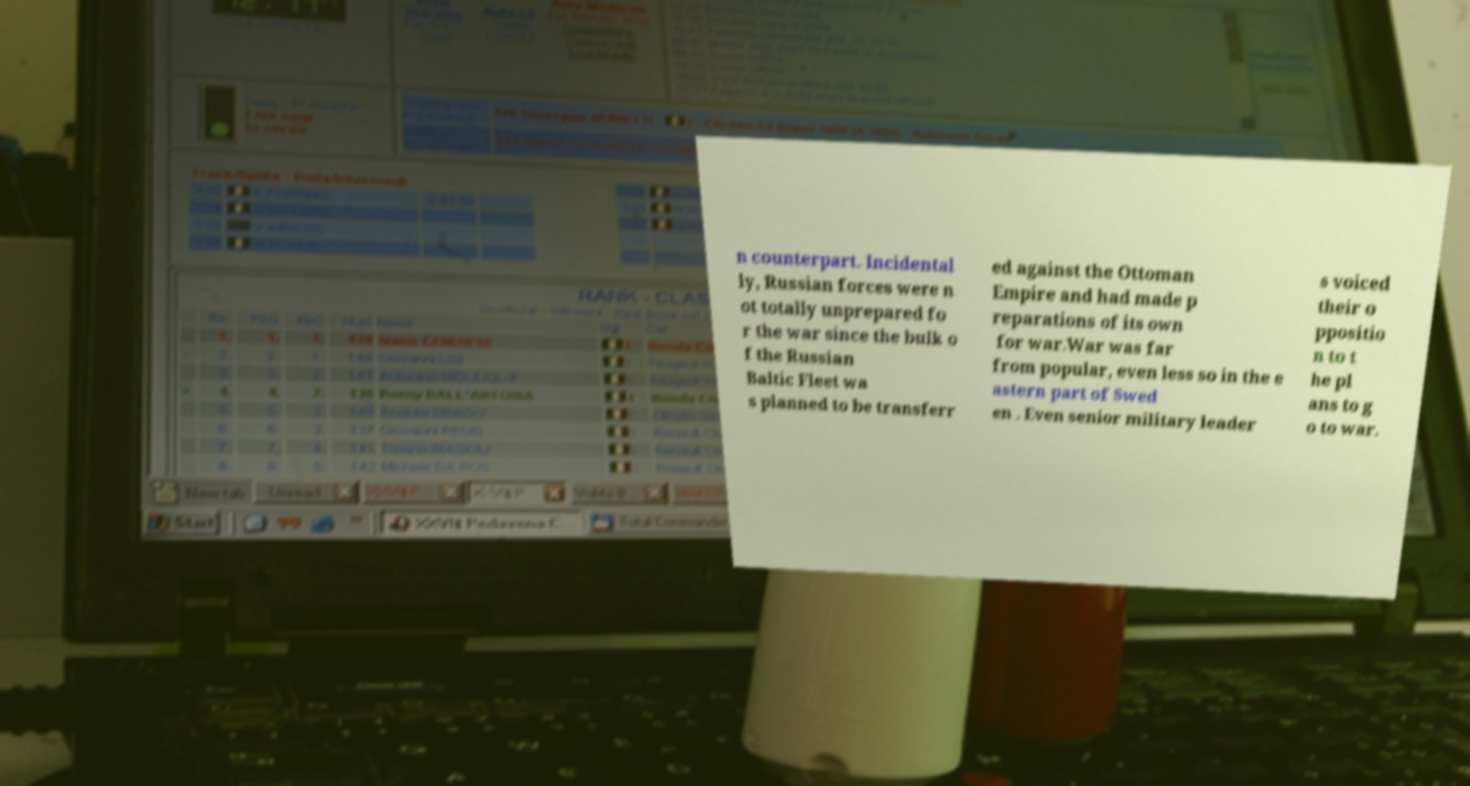What messages or text are displayed in this image? I need them in a readable, typed format. n counterpart. Incidental ly, Russian forces were n ot totally unprepared fo r the war since the bulk o f the Russian Baltic Fleet wa s planned to be transferr ed against the Ottoman Empire and had made p reparations of its own for war.War was far from popular, even less so in the e astern part of Swed en . Even senior military leader s voiced their o ppositio n to t he pl ans to g o to war. 